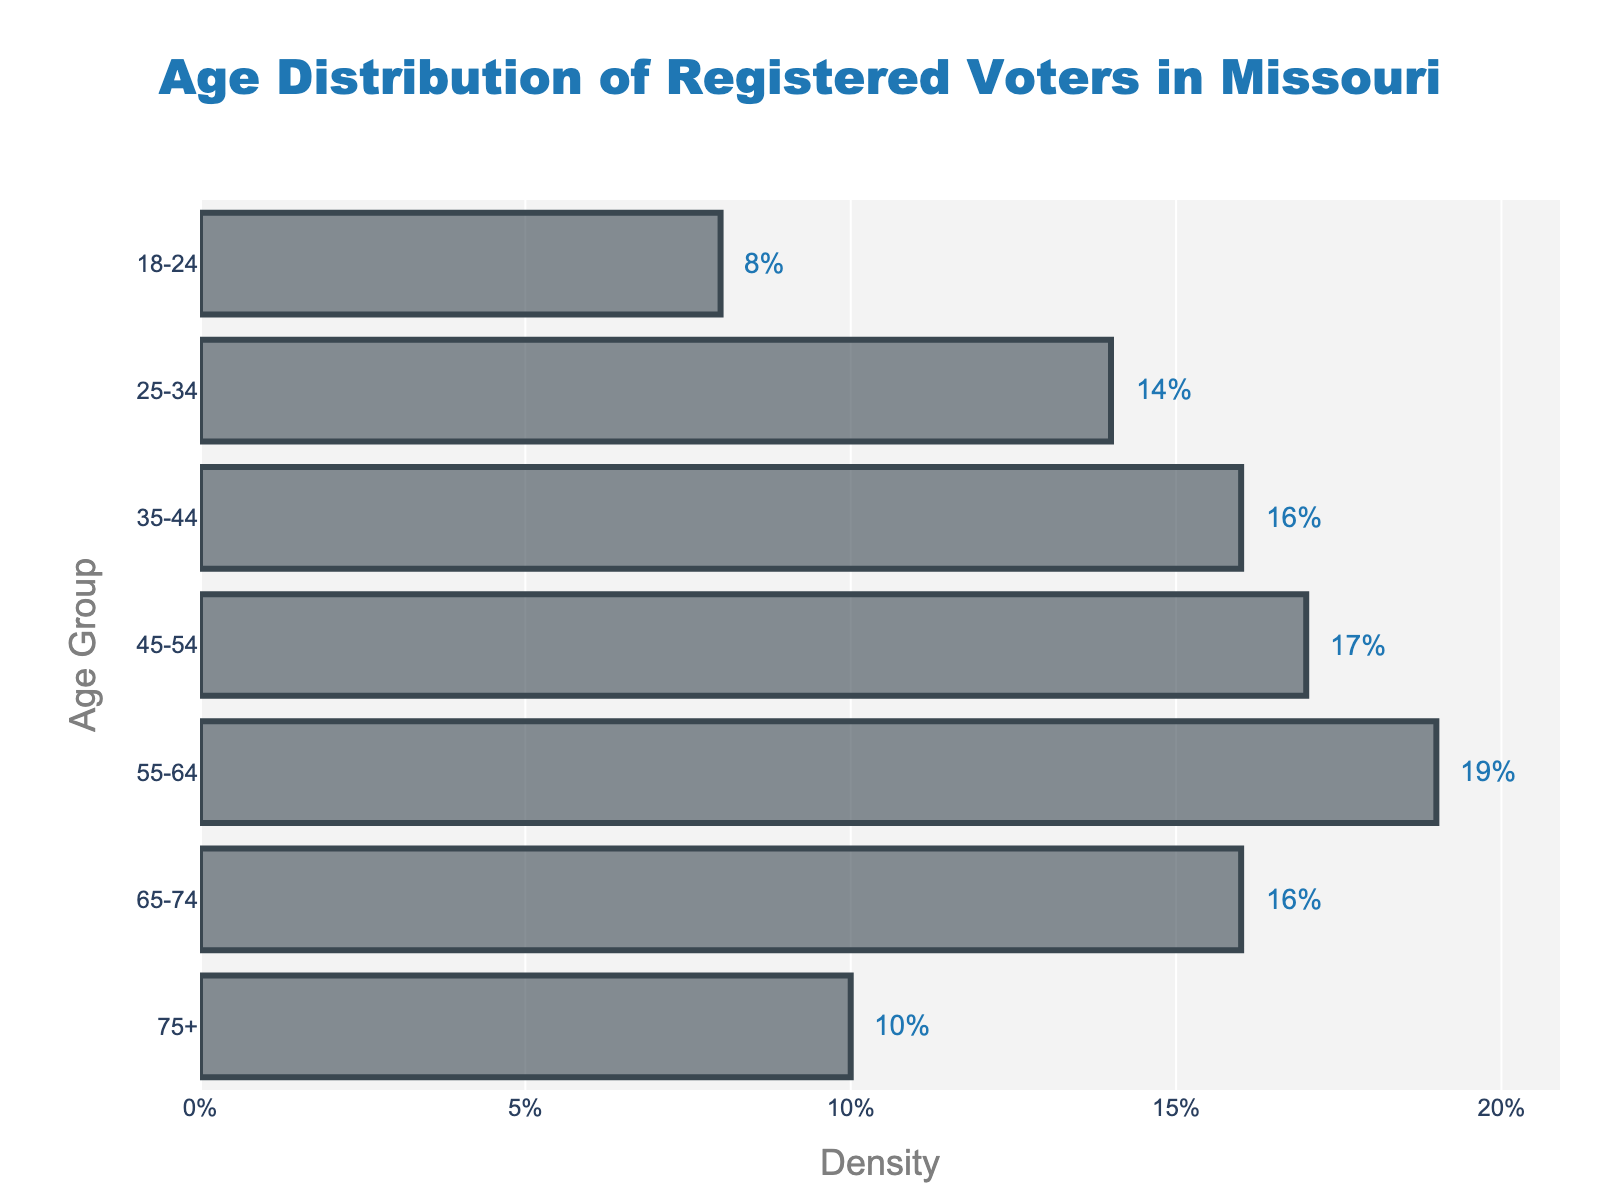What is the age group with the highest voter density? The highest voter density is represented by the longest horizontal bar in the plot. The '55-64' age group has a density of 0.19, which is the highest among all age groups.
Answer: 55-64 Which age group has the second lowest voter density? The second lowest voter density is the second shortest bar. The '75+' age group has a density of 0.10, which is higher than '18-24' but lower than all the other age groups.
Answer: 75+ What percentage of the voters are in the '25-34' age group? The density value for the '25-34' age group is 0.14. Therefore, 14% of the voters are in this age group.
Answer: 14% How does the voter density in the '35-44' age group compare to that in the '65-74' age group? Comparing the lengths of the bars, both '35-44' and '65-74' age groups have a density of 0.16. This indicates they have the same voter density.
Answer: Equal If you sum the densities of the '45-54' and '55-64' age groups, what is the total density? The density for '45-54' is 0.17 and for '55-64' is 0.19. Summing them gives 0.17 + 0.19 = 0.36.
Answer: 0.36 Which age group has more voters, '18-24' or '75+'? By comparing the lengths of the bars, the '75+' age group has a higher density (0.10) compared to the '18-24' age group (0.08).
Answer: 75+ What is the total percentage of voters aged 45 to 64? Add the densities for '45-54' and '55-64': 0.17 + 0.19 = 0.36. Thus, 36% of voters are aged 45 to 64.
Answer: 36% Which age group has the median voter density, and what is it? To find the median, list the densities in order: 0.08, 0.10, 0.14, 0.16, 0.16, 0.17, 0.19. The middle value is 0.16, so the '35-44' and '65-74' age groups have the median density.
Answer: 0.16 